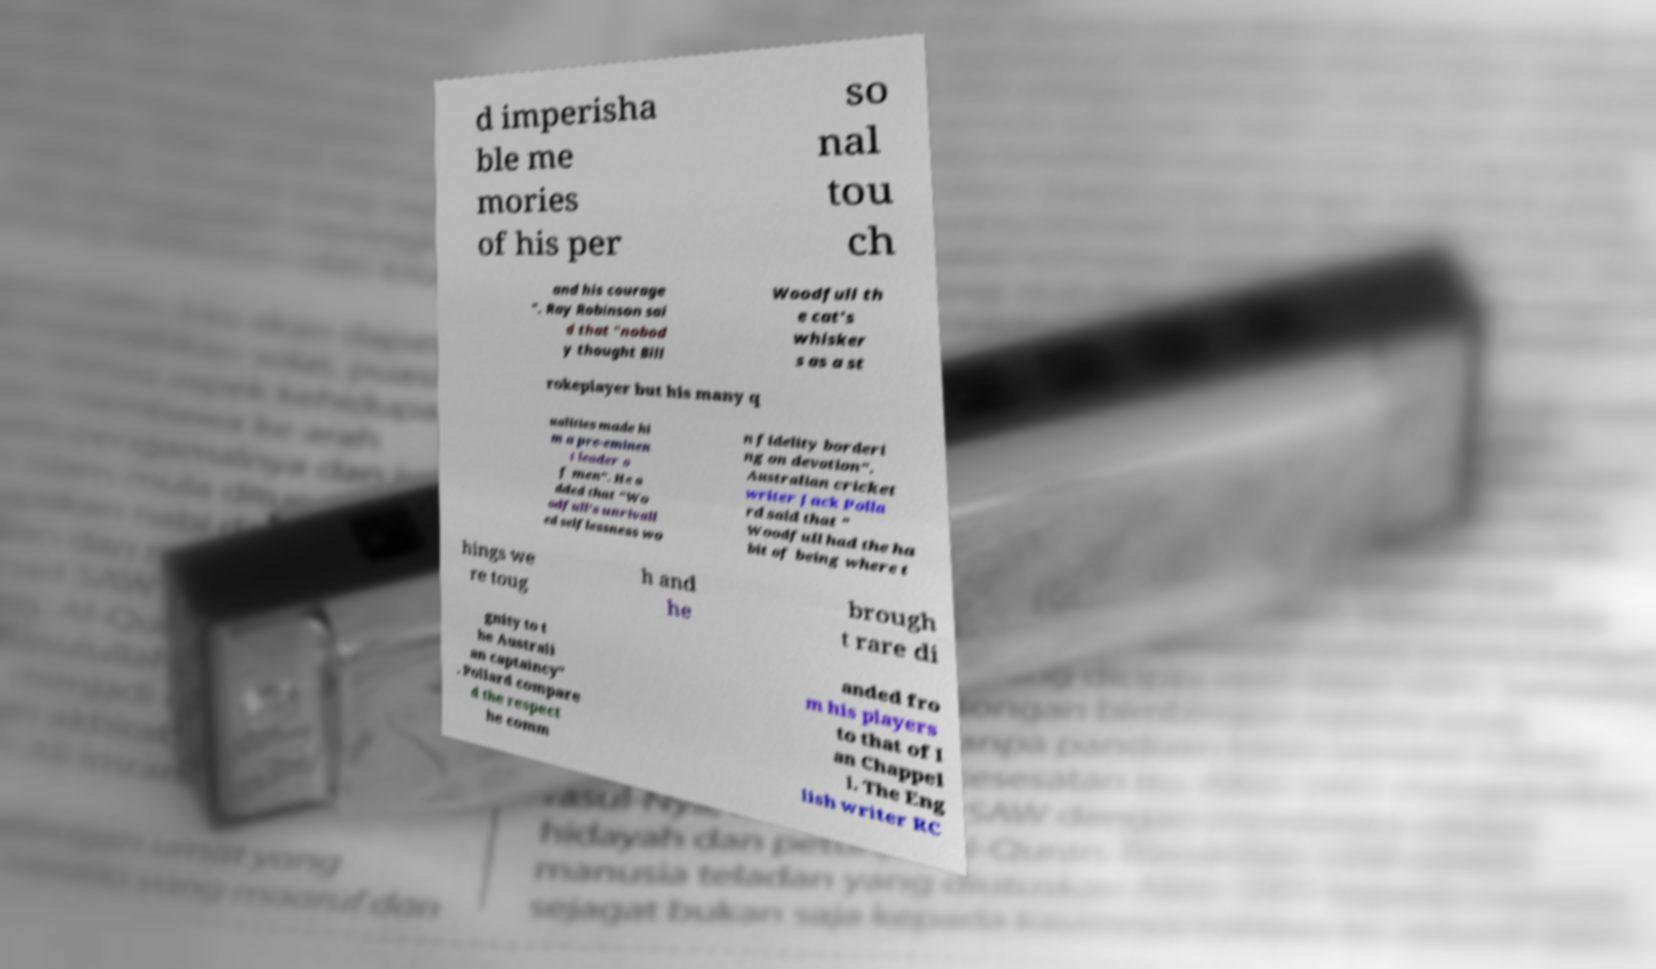There's text embedded in this image that I need extracted. Can you transcribe it verbatim? d imperisha ble me mories of his per so nal tou ch and his courage ". Ray Robinson sai d that "nobod y thought Bill Woodfull th e cat's whisker s as a st rokeplayer but his many q ualities made hi m a pre-eminen t leader o f men". He a dded that "Wo odfull's unrivall ed selflessness wo n fidelity borderi ng on devotion". Australian cricket writer Jack Polla rd said that " Woodfull had the ha bit of being where t hings we re toug h and he brough t rare di gnity to t he Australi an captaincy" . Pollard compare d the respect he comm anded fro m his players to that of I an Chappel l. The Eng lish writer RC 